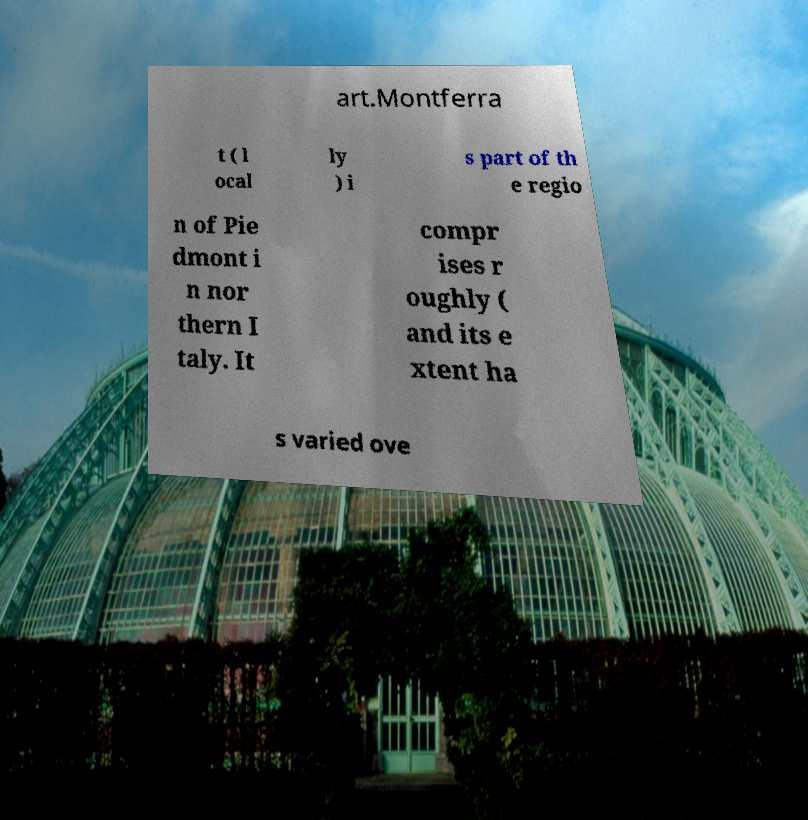Can you accurately transcribe the text from the provided image for me? art.Montferra t ( l ocal ly ) i s part of th e regio n of Pie dmont i n nor thern I taly. It compr ises r oughly ( and its e xtent ha s varied ove 